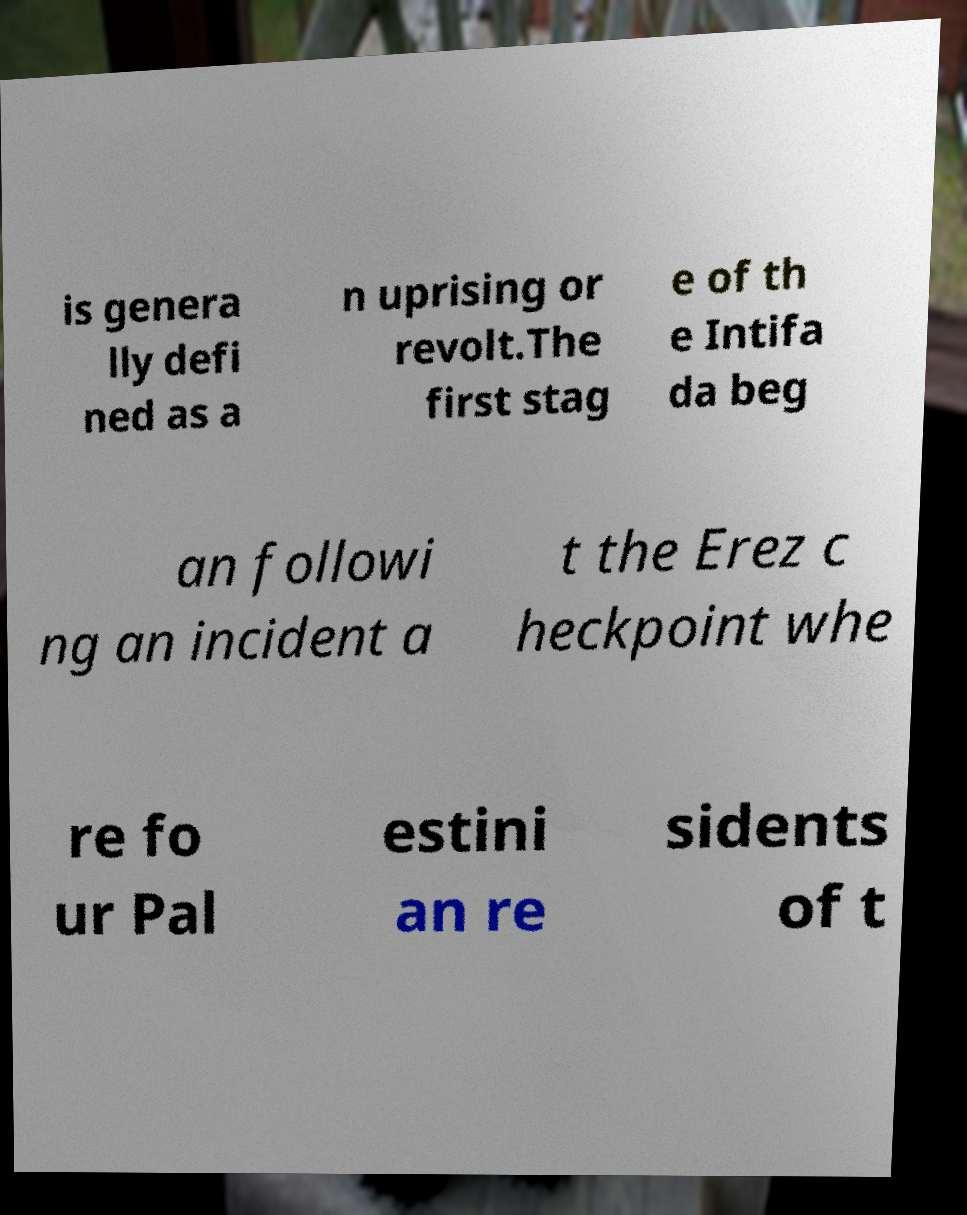What messages or text are displayed in this image? I need them in a readable, typed format. is genera lly defi ned as a n uprising or revolt.The first stag e of th e Intifa da beg an followi ng an incident a t the Erez c heckpoint whe re fo ur Pal estini an re sidents of t 